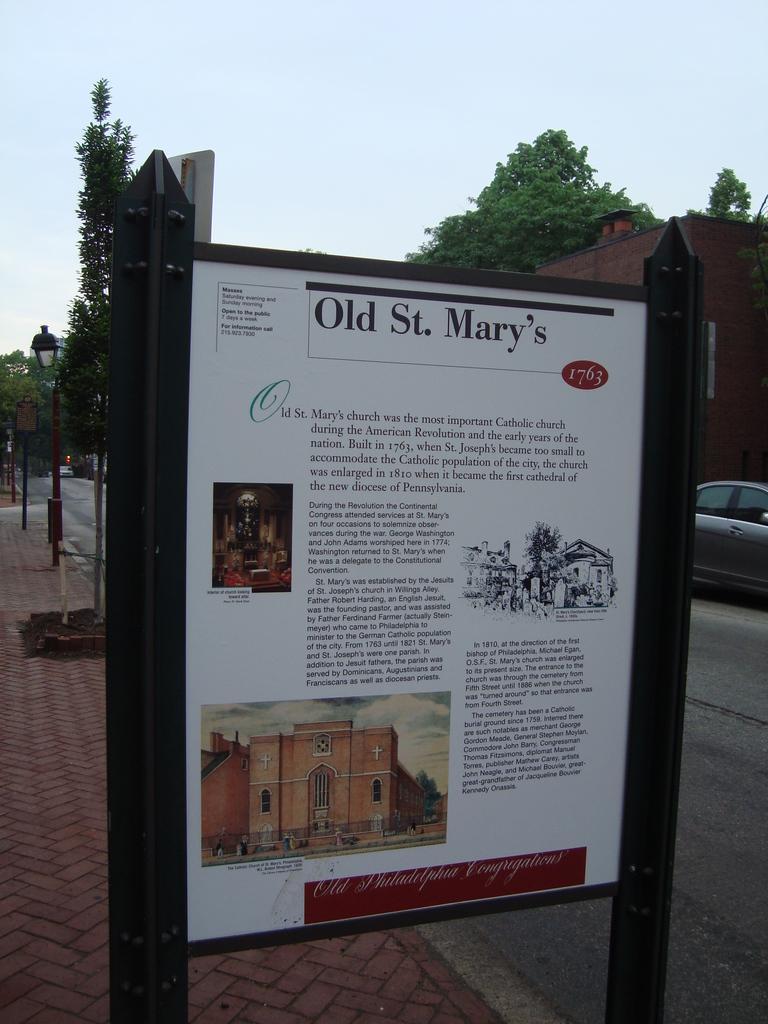Could you give a brief overview of what you see in this image? In this picture we can see some vehicles are on the road, side we can see some buildings, trees and also some boards. 